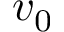<formula> <loc_0><loc_0><loc_500><loc_500>v _ { 0 }</formula> 